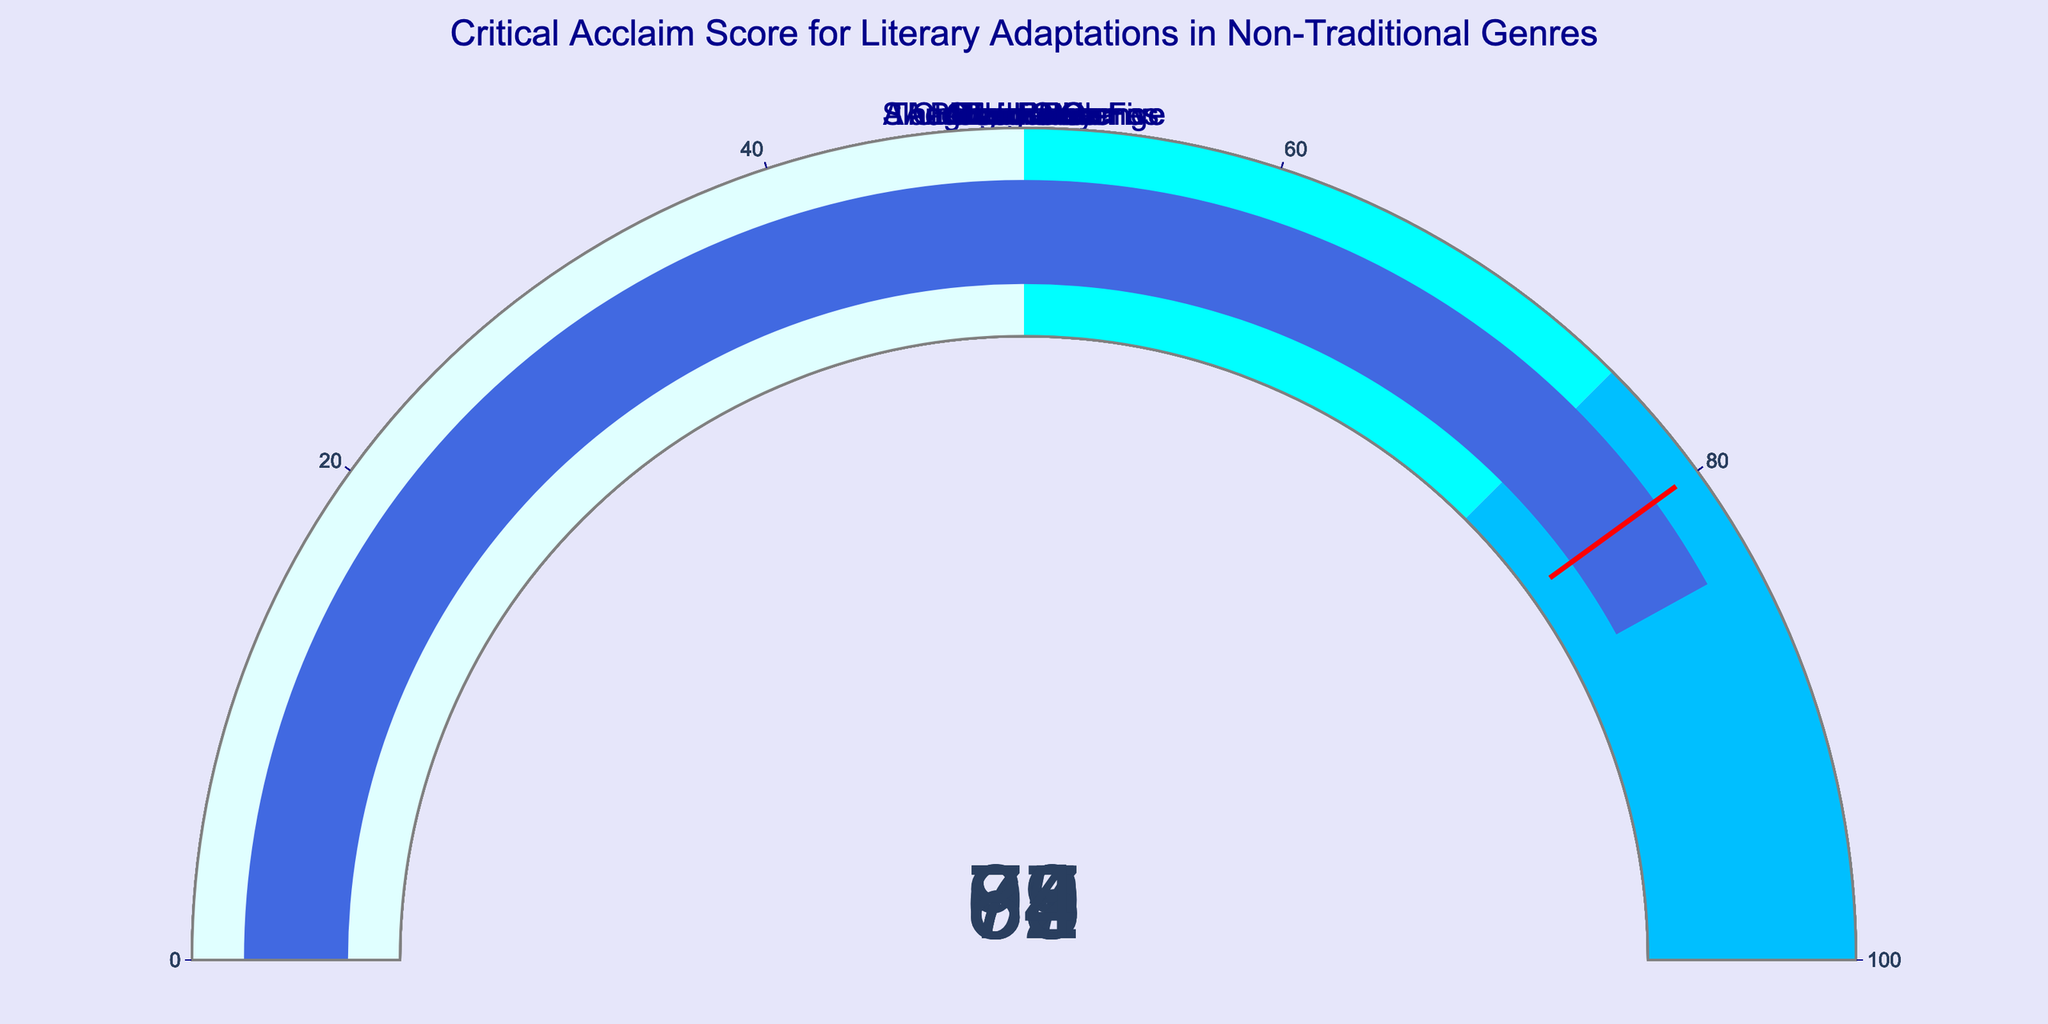What is the Critical Acclaim Score for "Blade Runner"? Look at the gauge chart for "Blade Runner". The indicated number on the gauge is the Critical Acclaim Score.
Answer: 92 Which adaptation has the lowest Critical Acclaim Score? Identify the gauge with the lowest value among all. "Watchmen" has the lowest score, which is 65.
Answer: Watchmen Which two adaptations have the highest Critical Acclaim Scores and what are their values? Find the two gauges with the highest values. "Blade Runner" and "A Clockwork Orange" have the highest scores of 92 and 88, respectively.
Answer: Blade Runner: 92, A Clockwork Orange: 88 What is the average Critical Acclaim Score of all the adaptations? Sum up all the scores and divide by the number of adaptations. Sum: 87 + 69 + 78 + 92 + 65 + 79 + 88 + 72 + 75 + 84 = 789. Number of adaptations: 10. Average: 789 / 10 = 78.9
Answer: 78.9 How many adaptations have a score greater than 80? Count the gauges with values above 80. "The Hunger Games", "Blade Runner", "A Clockwork Orange", and "Annihilation" have scores above 80. Therefore, there are 4 adaptations.
Answer: 4 Which adaptation has a score closest to the median score of all adaptations? Arrange scores in ascending order: 65, 69, 72, 75, 78, 79, 84, 87, 88, 92. Median (the middle value for this ordered list) = (78 + 79) / 2 = 78.5. "Fight Club" with 79 is closest to the median.
Answer: Fight Club List the scores of the adaptations that fall in the "deepskyblue" range (75-100). Identify the gauges with values in the range 75 to 100. "The Hunger Games" (87), "American Psycho" (78), "Blade Runner" (92), "Fight Club" (79), "A Clockwork Orange" (88), "Annihilation" (84).
Answer: 87, 78, 92, 79, 88, 84 What is the difference between the highest and lowest Critical Acclaim Scores? Subtract the lowest score from the highest score. Maximum: 92 (Blade Runner), Minimum: 65 (Watchmen). Difference: 92 - 65 = 27
Answer: 27 How many adaptations have a Critical Acclaim Score between 70 and 85? Count the gauges with values between 70 and 85. "Cloud Atlas" (69), "American Psycho" (78), "Fight Club" (79), "A Clockwork Orange" (88), "Slaughterhouse-Five" (72), "The Road" (75), "Annihilation" (84). Exclude those outside the range. Results: "American Psycho", "Fight Club", "Slaughterhouse-Five", "The Road", "Annihilation". Count: 5.
Answer: 5 